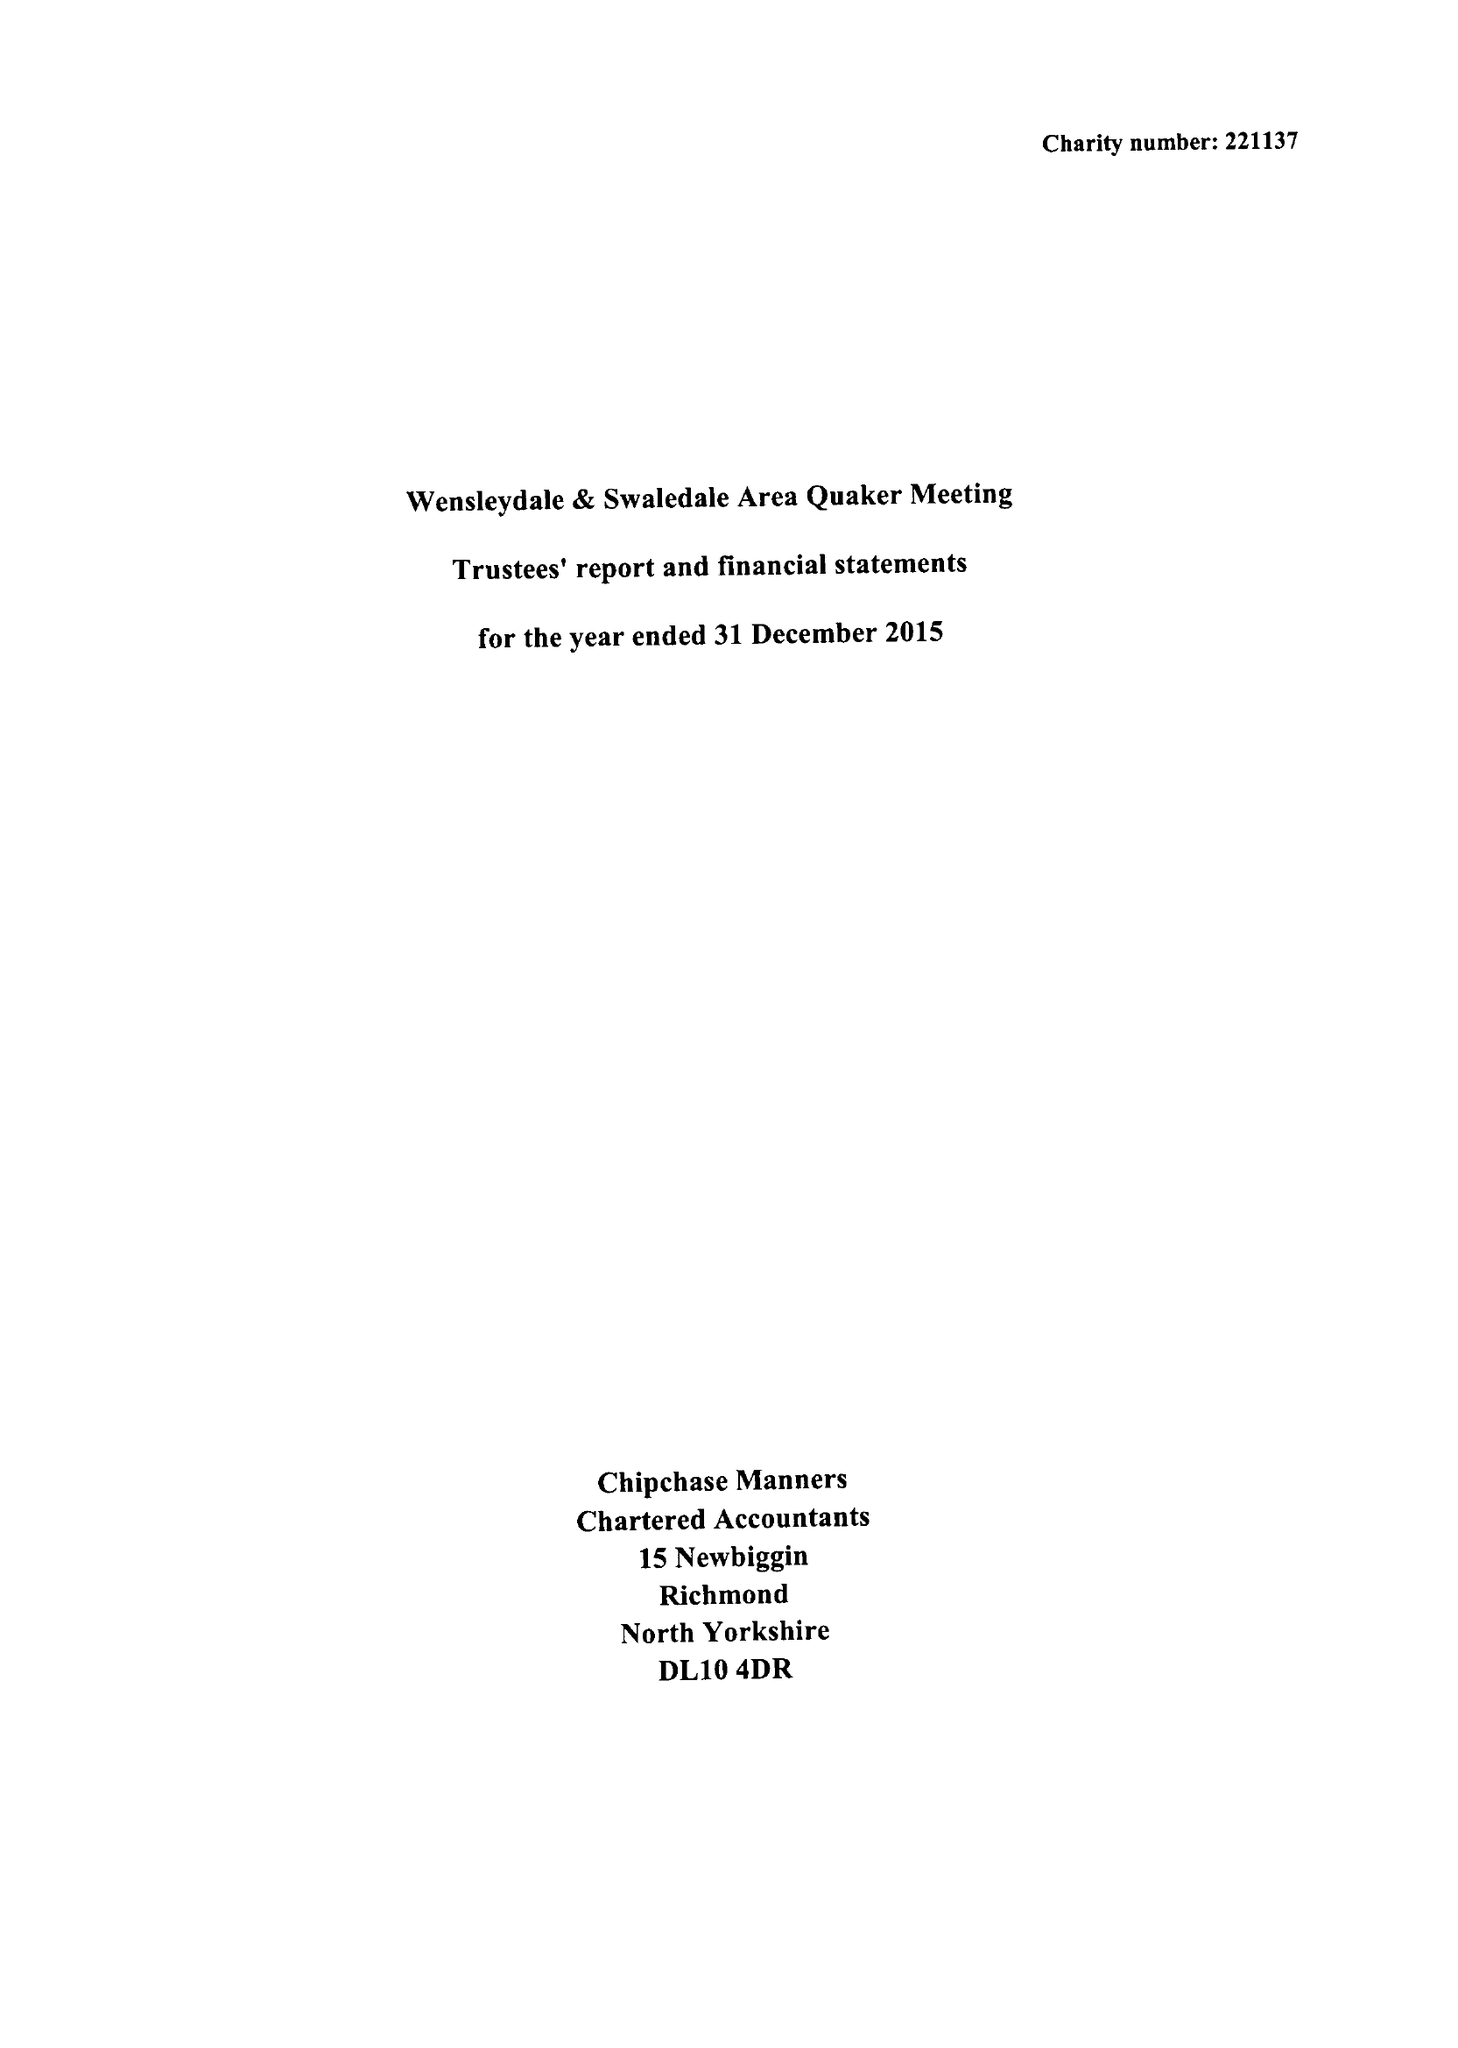What is the value for the charity_number?
Answer the question using a single word or phrase. 221137 